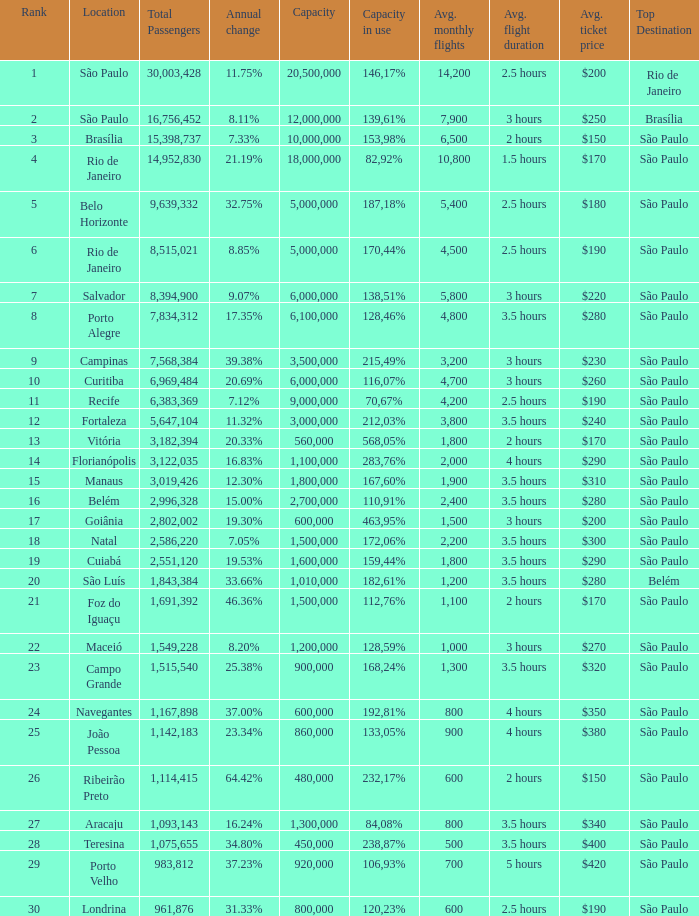What location has an in use capacity of 167,60%? 1800000.0. 